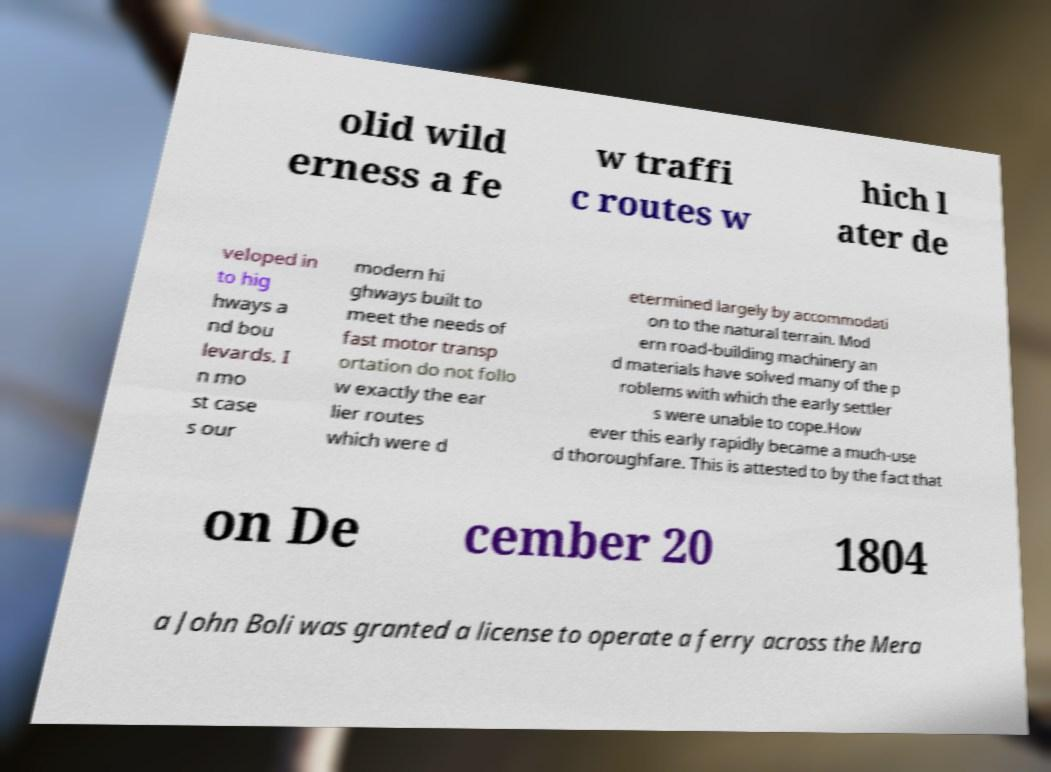I need the written content from this picture converted into text. Can you do that? olid wild erness a fe w traffi c routes w hich l ater de veloped in to hig hways a nd bou levards. I n mo st case s our modern hi ghways built to meet the needs of fast motor transp ortation do not follo w exactly the ear lier routes which were d etermined largely by accommodati on to the natural terrain. Mod ern road-building machinery an d materials have solved many of the p roblems with which the early settler s were unable to cope.How ever this early rapidly became a much-use d thoroughfare. This is attested to by the fact that on De cember 20 1804 a John Boli was granted a license to operate a ferry across the Mera 